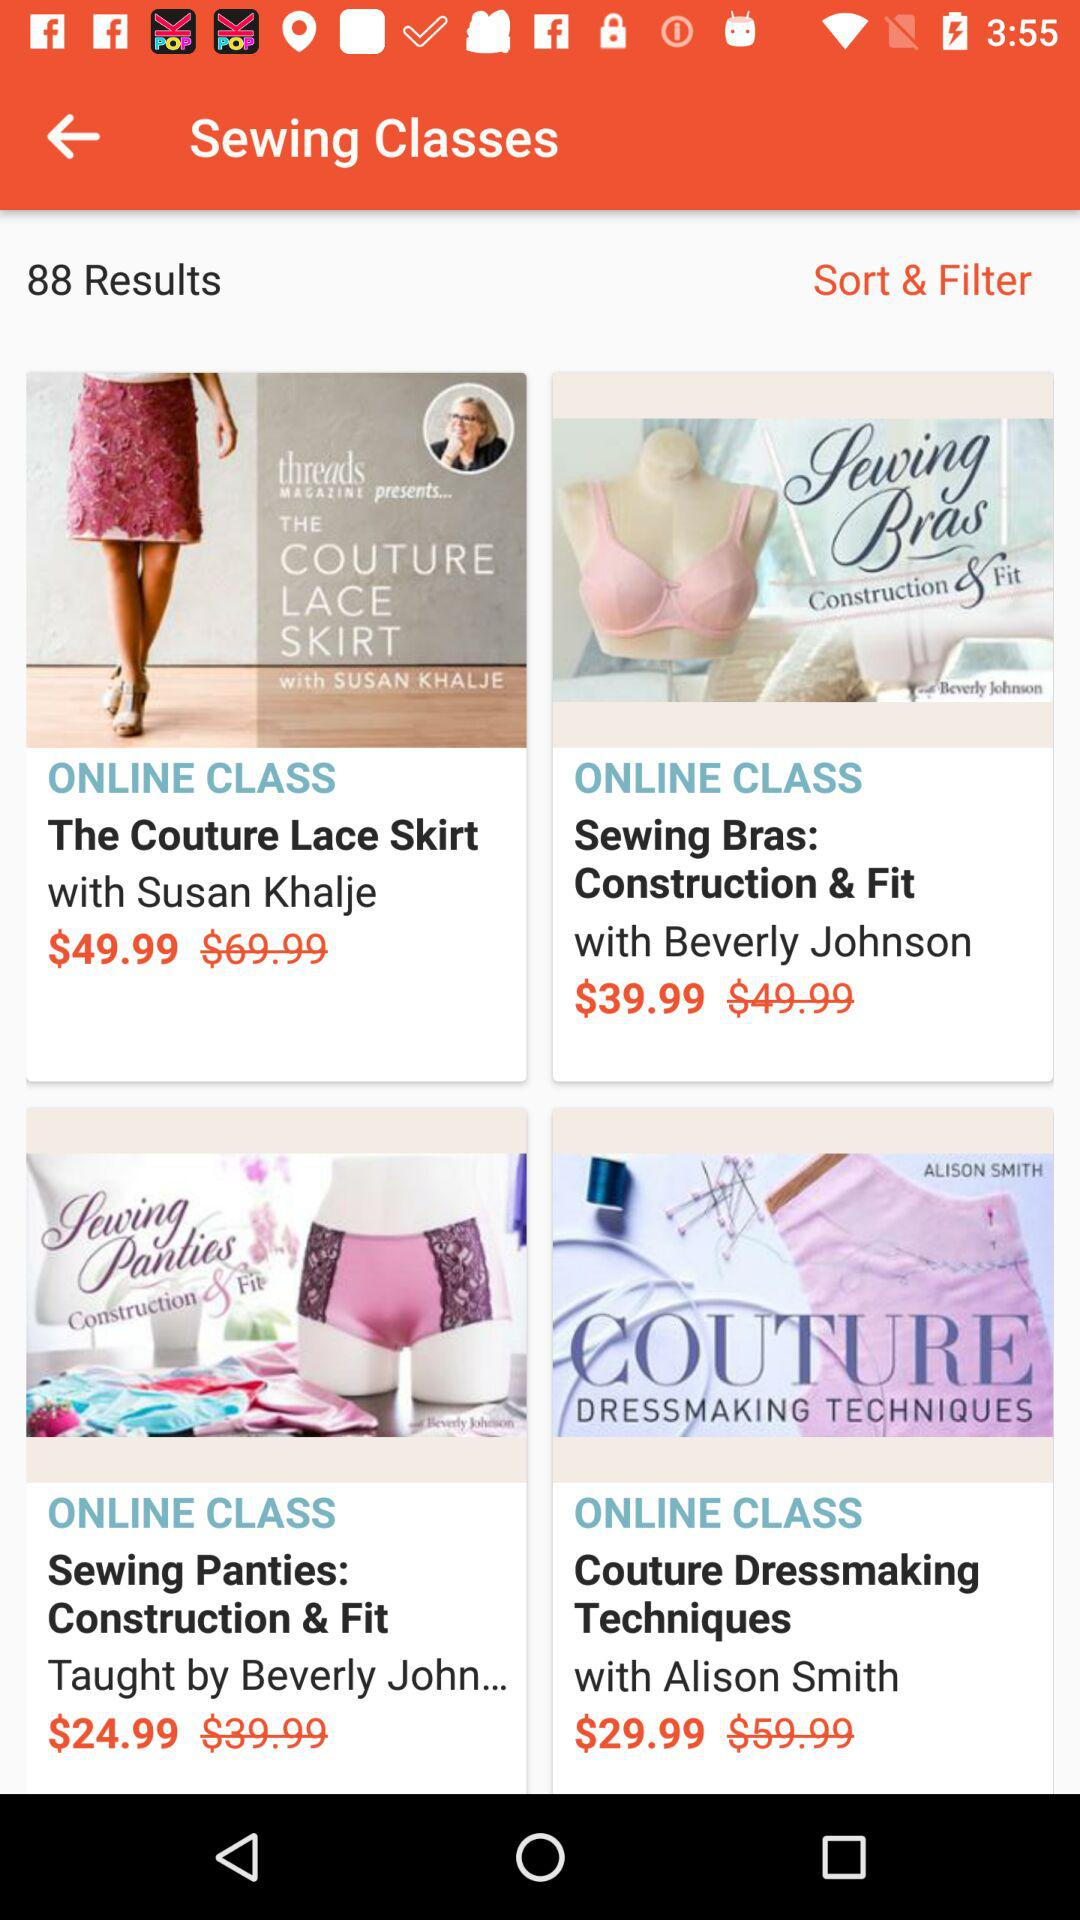What is the original price of sewing bras? The original price is $49.99. 